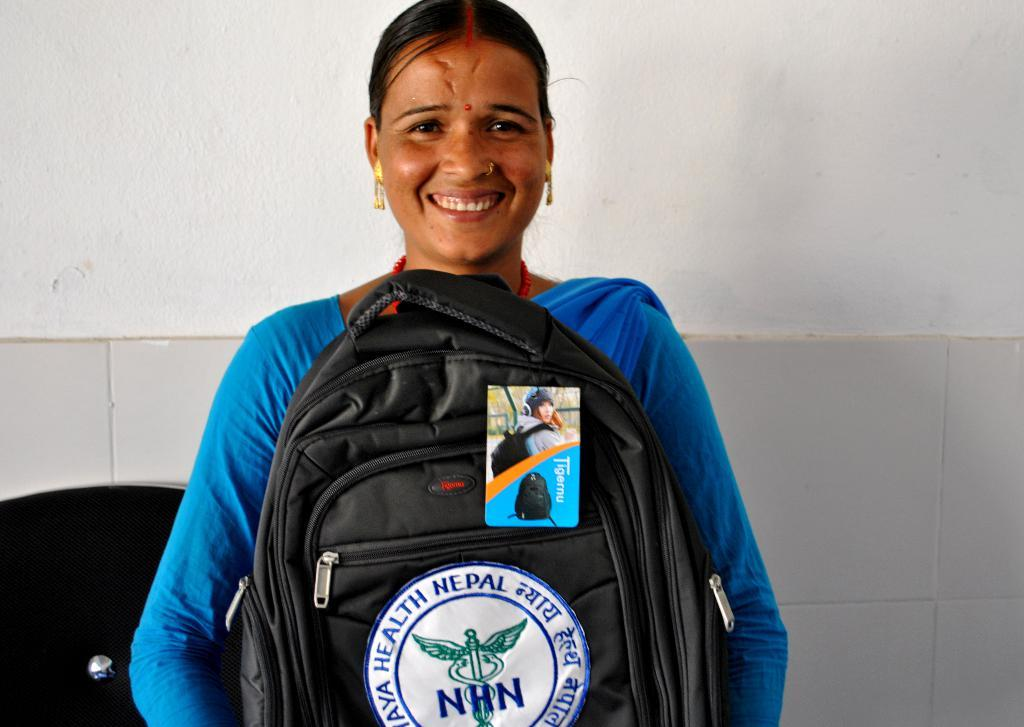<image>
Render a clear and concise summary of the photo. A lady wearing blue who is smiling and holding a black backpack with a tag and decal with NHN and a medical logo on it. 